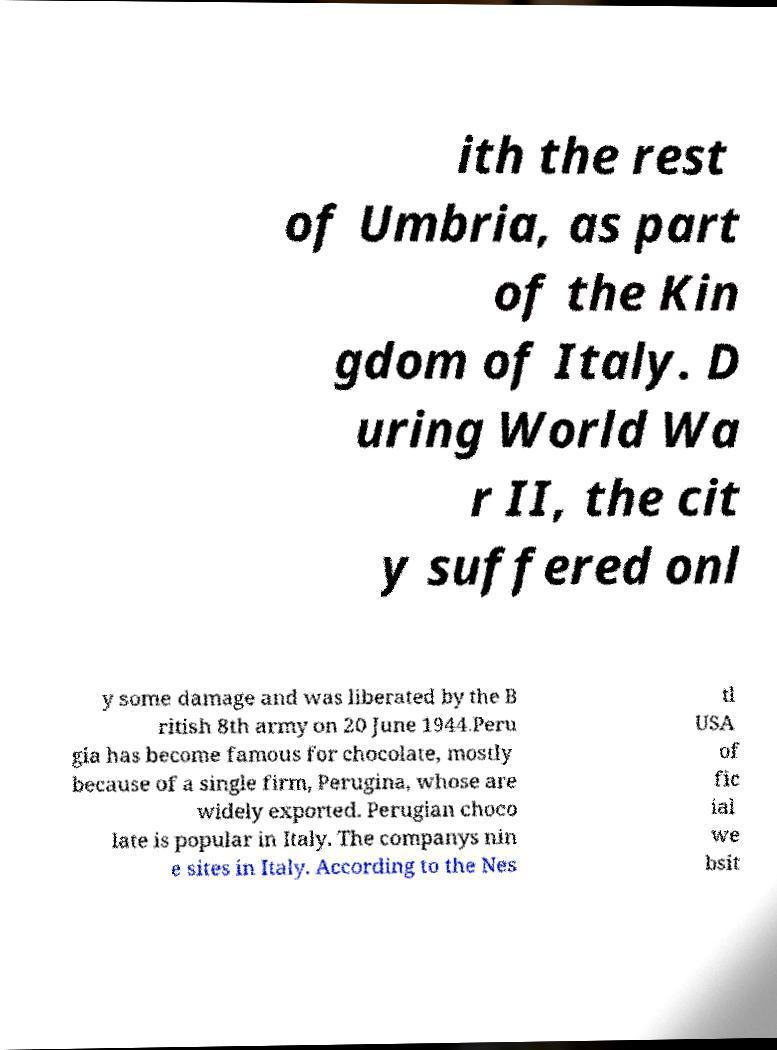Can you accurately transcribe the text from the provided image for me? ith the rest of Umbria, as part of the Kin gdom of Italy. D uring World Wa r II, the cit y suffered onl y some damage and was liberated by the B ritish 8th army on 20 June 1944.Peru gia has become famous for chocolate, mostly because of a single firm, Perugina, whose are widely exported. Perugian choco late is popular in Italy. The companys nin e sites in Italy. According to the Nes tl USA of fic ial we bsit 